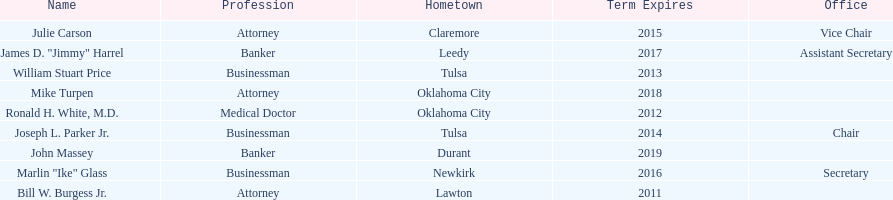Other members of the state regents from tulsa besides joseph l. parker jr. William Stuart Price. 